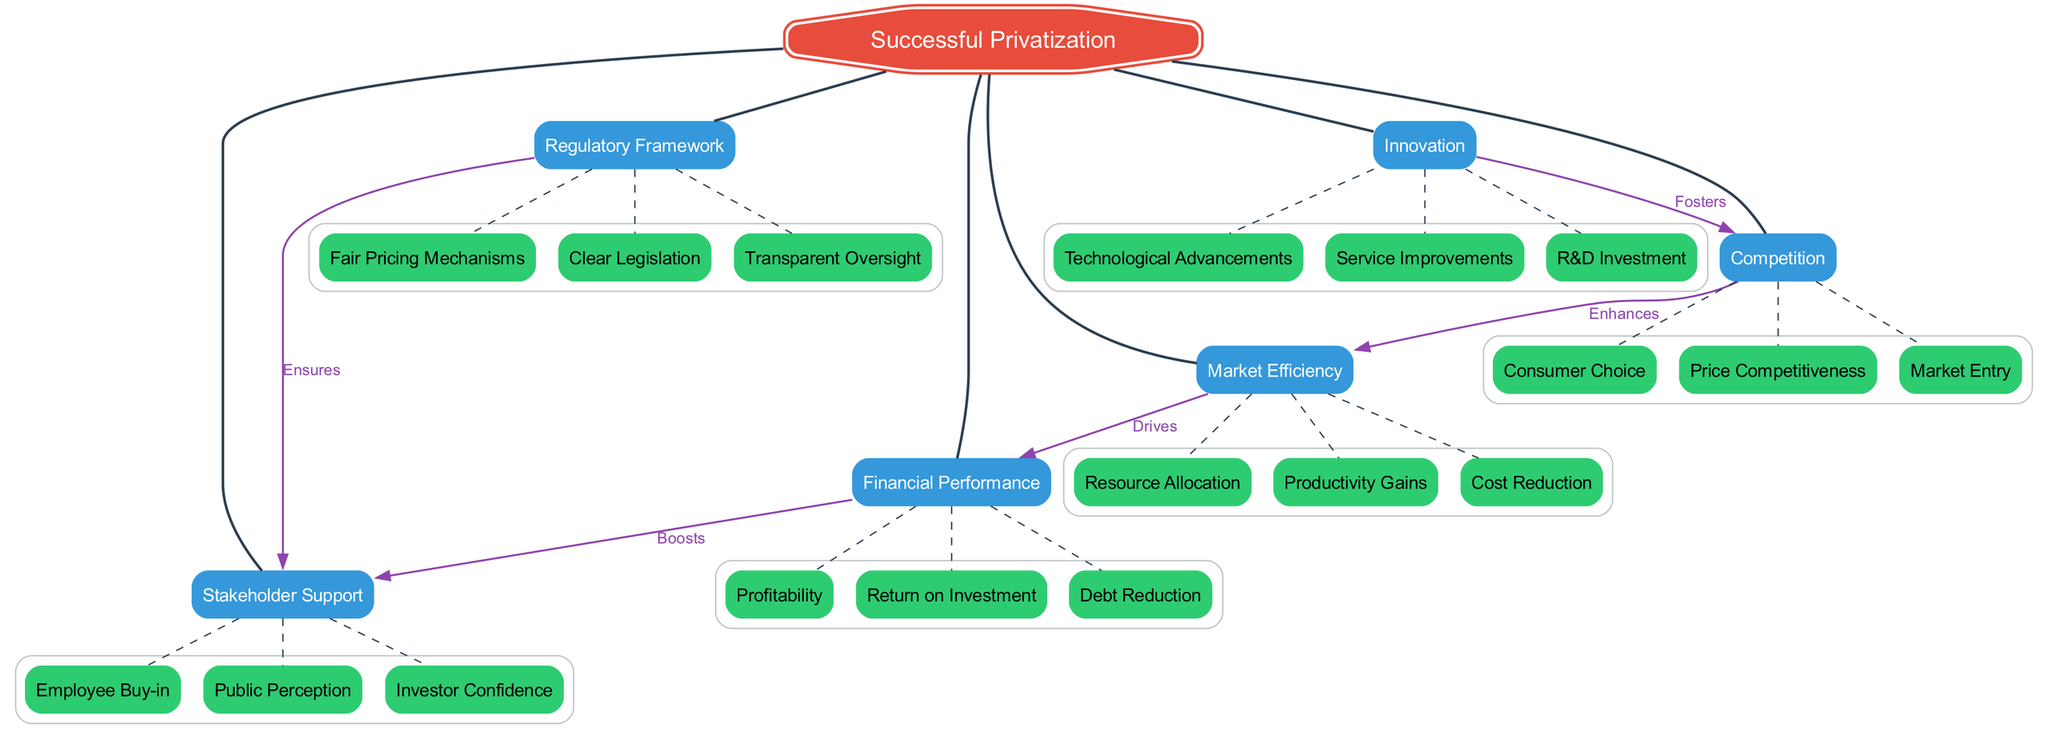What is the central concept of the diagram? The diagram's central concept is "Successful Privatization," which is represented at the top as the primary focus of the concept map.
Answer: Successful Privatization How many main nodes does the diagram have? There are six main nodes listed directly connected to the central concept. They are Market Efficiency, Regulatory Framework, Stakeholder Support, Financial Performance, Innovation, and Competition.
Answer: 6 What drives financial performance in this diagram? The diagram indicates that "Market Efficiency" drives "Financial Performance," as shown by the labeled connection from Market Efficiency to Financial Performance.
Answer: Market Efficiency Which sub-node is associated with regulatory framework? The regulatory framework has three sub-nodes listed: Clear Legislation, Transparent Oversight, and Fair Pricing Mechanisms. Any of these can be valid answers, but one specific sub-node is "Clear Legislation."
Answer: Clear Legislation What is the relationship between innovation and competition? The relationship is that "Innovation" fosters "Competition," demonstrated by the directed edge with the "Fosters" label connecting these two main nodes.
Answer: Fosters Which main node boosts stakeholder support? The main node that boosts stakeholder support is "Financial Performance," as illustrated by the directed connection from Financial Performance to Stakeholder Support with the label "Boosts."
Answer: Financial Performance What enhances market efficiency? According to the diagram, "Competition" enhances "Market Efficiency," as depicted by the connection between these two nodes labeled "Enhances."
Answer: Competition What is one sub-node of innovation? The innovation node includes several sub-nodes, with "Technological Advancements" being one of the valid examples that can be found connected under innovation.
Answer: Technological Advancements What ensures stakeholder support according to the diagram? The diagram states that "Regulatory Framework" ensures "Stakeholder Support," indicated by the labeled connection between these two nodes.
Answer: Regulatory Framework 